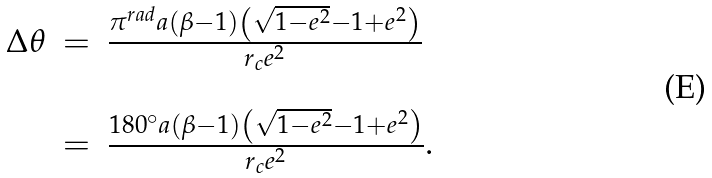<formula> <loc_0><loc_0><loc_500><loc_500>\begin{array} { l l l } \Delta \theta & = & \frac { { { \pi ^ { r a d } } a \left ( { \beta - 1 } \right ) \left ( { \sqrt { 1 - e ^ { 2 } } - 1 + e ^ { 2 } } \right ) } } { r _ { c } e ^ { 2 } } \\ & & \\ & = & \frac { { { 1 8 0 ^ { \circ } } a \left ( { \beta - 1 } \right ) \left ( { \sqrt { 1 - e ^ { 2 } } - 1 + e ^ { 2 } } \right ) } } { r _ { c } e ^ { 2 } } . \end{array}</formula> 